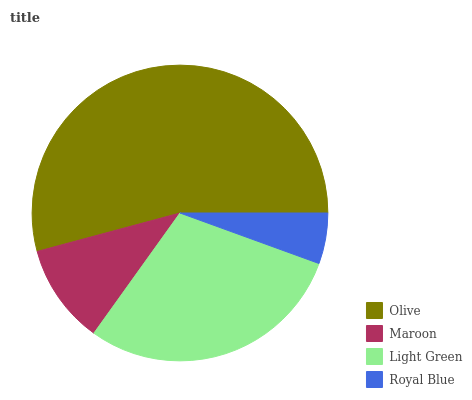Is Royal Blue the minimum?
Answer yes or no. Yes. Is Olive the maximum?
Answer yes or no. Yes. Is Maroon the minimum?
Answer yes or no. No. Is Maroon the maximum?
Answer yes or no. No. Is Olive greater than Maroon?
Answer yes or no. Yes. Is Maroon less than Olive?
Answer yes or no. Yes. Is Maroon greater than Olive?
Answer yes or no. No. Is Olive less than Maroon?
Answer yes or no. No. Is Light Green the high median?
Answer yes or no. Yes. Is Maroon the low median?
Answer yes or no. Yes. Is Olive the high median?
Answer yes or no. No. Is Royal Blue the low median?
Answer yes or no. No. 